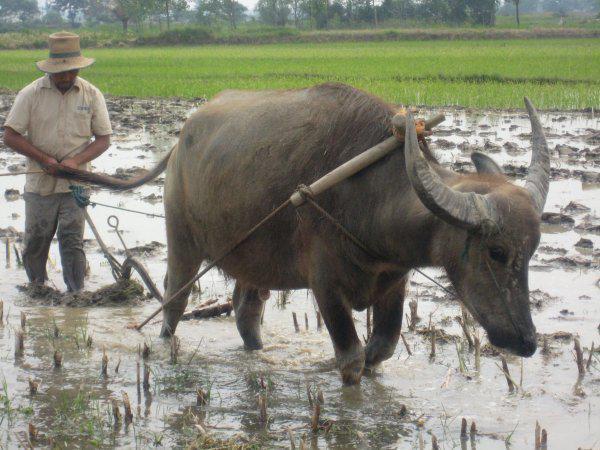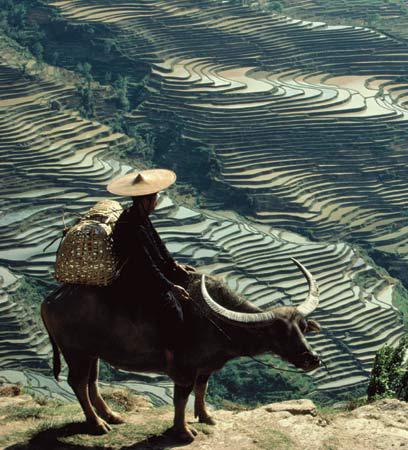The first image is the image on the left, the second image is the image on the right. Analyze the images presented: Is the assertion "Each image shows a person walking behind an ox pulling a tiller" valid? Answer yes or no. No. The first image is the image on the left, the second image is the image on the right. For the images displayed, is the sentence "The right image shows one woman walking leftward behind a plow pulled by one ox through a wet field, and the left image shows one man walking rightward behind a plow pulled by one ox through a wet field." factually correct? Answer yes or no. No. 